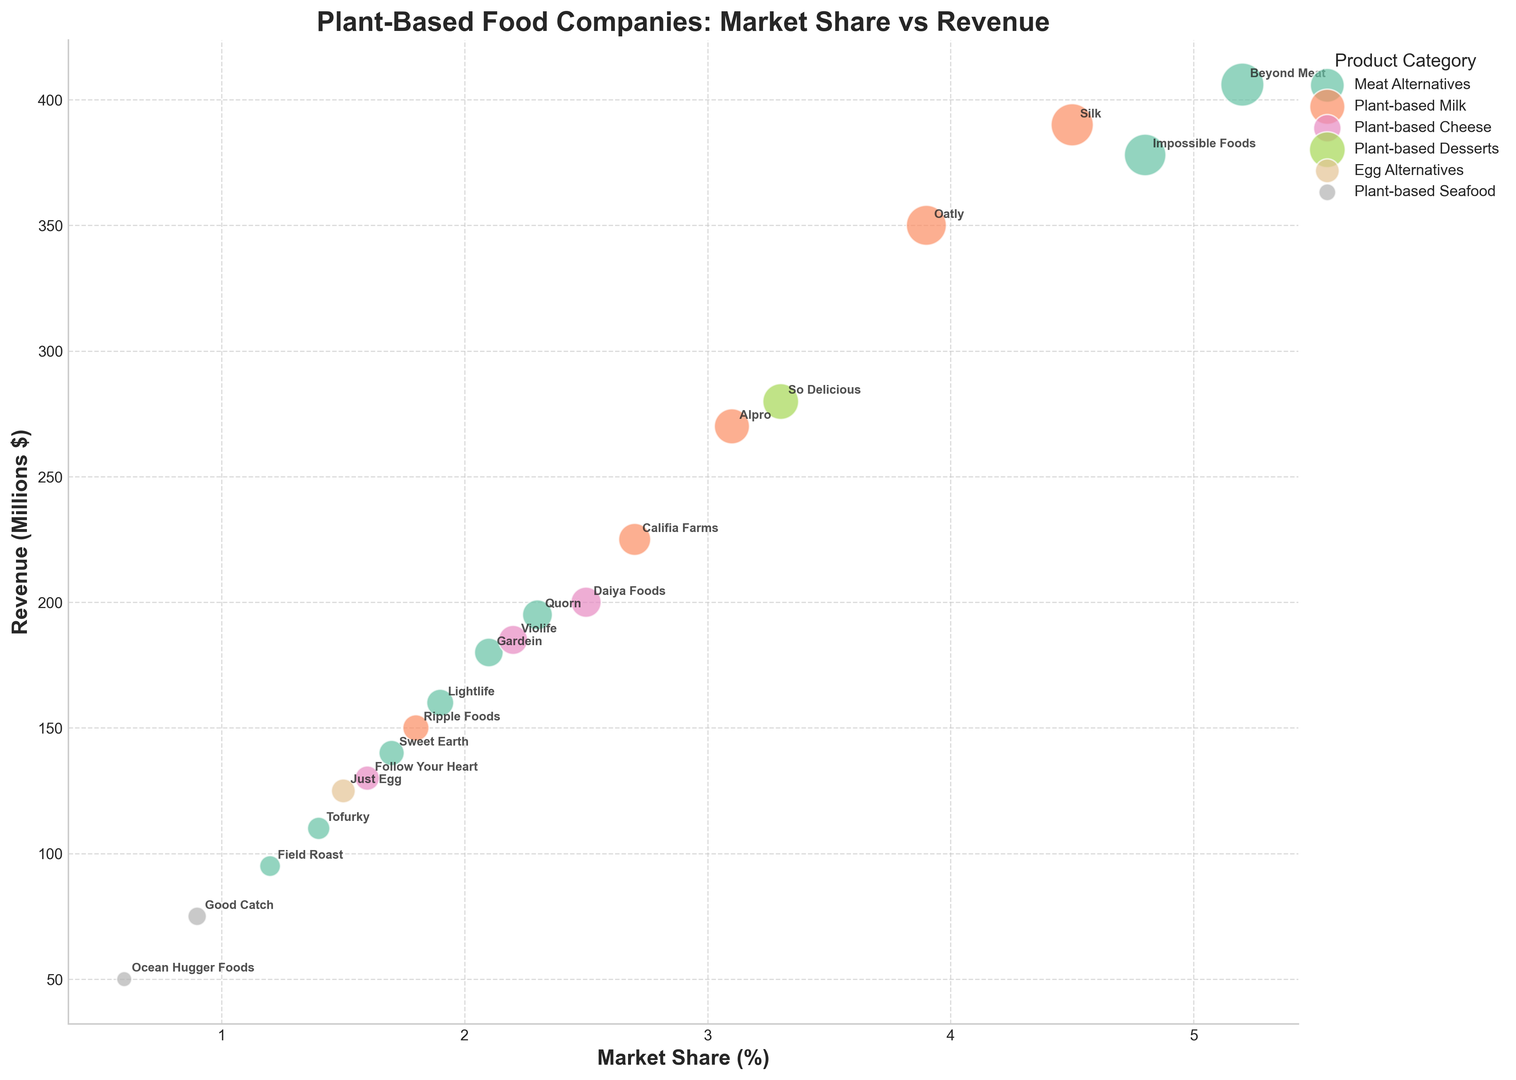Which company has the highest revenue in the plant-based cheese category? Look for the companies in the plant-based cheese category and compare their revenue values. Daiya Foods has the highest revenue of 200 million dollars.
Answer: Daiya Foods Which product category contains the company with both the highest market share and the highest revenue? Beyond Meat has the highest market share of 5.2% and the highest revenue of 406 million dollars. The product category is meat alternatives.
Answer: Meat Alternatives What is the total market share of all companies in the plant-based milk category? Sum up the market shares of Oatly (3.9), Califia Farms (2.7), Ripple Foods (1.8), Silk (4.5), and Alpro (3.1). The total market share is 3.9 + 2.7 + 1.8 + 4.5 + 3.1 = 16.0%.
Answer: 16.0% Among the top three companies by revenue in the meat alternatives category, which one has the lowest market share? The top three companies by revenue in the meat alternatives category are Beyond Meat (406), Impossible Foods (378), and Gardein (180). Compare their market shares: Beyond Meat (5.2%), Impossible Foods (4.8%), and Gardein (2.1%). Gardein has the lowest market share.
Answer: Gardein Compare the market share of So Delicious and Califia Farms, which one has a greater share and by how much? So Delicious has a market share of 3.3%, while Califia Farms has a market share of 2.7%. The difference is 3.3 - 2.7 = 0.6%. So Delicious has a greater market share by 0.6%.
Answer: So Delicious by 0.6% Which company in the plant-based seafood category has the higher revenue? Compare the revenues of Good Catch (75 million dollars) and Ocean Hugger Foods (50 million dollars). Good Catch has the higher revenue.
Answer: Good Catch Which company has the smallest bubble size in the chart, and what does this represent? Look for the smallest bubble in the chart. Ocean Hugger Foods has the smallest bubble size, representing the lowest revenue of 50 million dollars.
Answer: Ocean Hugger Foods What is the combined revenue of companies in the plant-based desserts and egg alternatives categories? Add the revenues of companies in both categories: So Delicious (280) in plant-based desserts and Just Egg (125) in egg alternatives. The combined revenue is 280 + 125 = 405 million dollars.
Answer: 405 million dollars Which company within the plant-based cheese category has the closest market share to Follow Your Heart? Compare the market share of Follow Your Heart (1.6%) with other companies in the plant-based cheese category. Violife has a market share of 2.2%, which is the closest.
Answer: Violife 